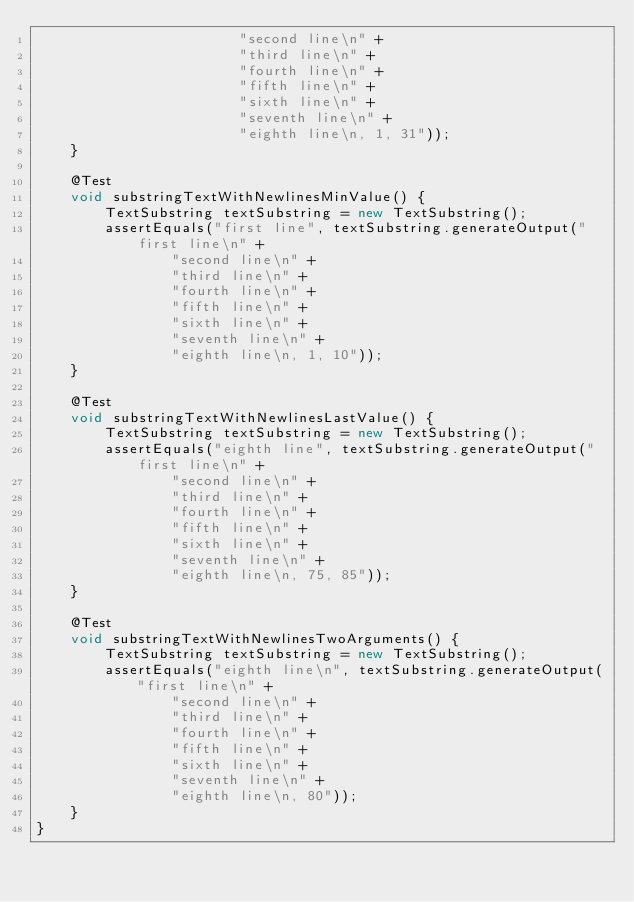Convert code to text. <code><loc_0><loc_0><loc_500><loc_500><_Java_>                        "second line\n" +
                        "third line\n" +
                        "fourth line\n" +
                        "fifth line\n" +
                        "sixth line\n" +
                        "seventh line\n" +
                        "eighth line\n, 1, 31"));
    }

    @Test
    void substringTextWithNewlinesMinValue() {
        TextSubstring textSubstring = new TextSubstring();
        assertEquals("first line", textSubstring.generateOutput("first line\n" +
                "second line\n" +
                "third line\n" +
                "fourth line\n" +
                "fifth line\n" +
                "sixth line\n" +
                "seventh line\n" +
                "eighth line\n, 1, 10"));
    }

    @Test
    void substringTextWithNewlinesLastValue() {
        TextSubstring textSubstring = new TextSubstring();
        assertEquals("eighth line", textSubstring.generateOutput("first line\n" +
                "second line\n" +
                "third line\n" +
                "fourth line\n" +
                "fifth line\n" +
                "sixth line\n" +
                "seventh line\n" +
                "eighth line\n, 75, 85"));
    }

    @Test
    void substringTextWithNewlinesTwoArguments() {
        TextSubstring textSubstring = new TextSubstring();
        assertEquals("eighth line\n", textSubstring.generateOutput("first line\n" +
                "second line\n" +
                "third line\n" +
                "fourth line\n" +
                "fifth line\n" +
                "sixth line\n" +
                "seventh line\n" +
                "eighth line\n, 80"));
    }
}
</code> 